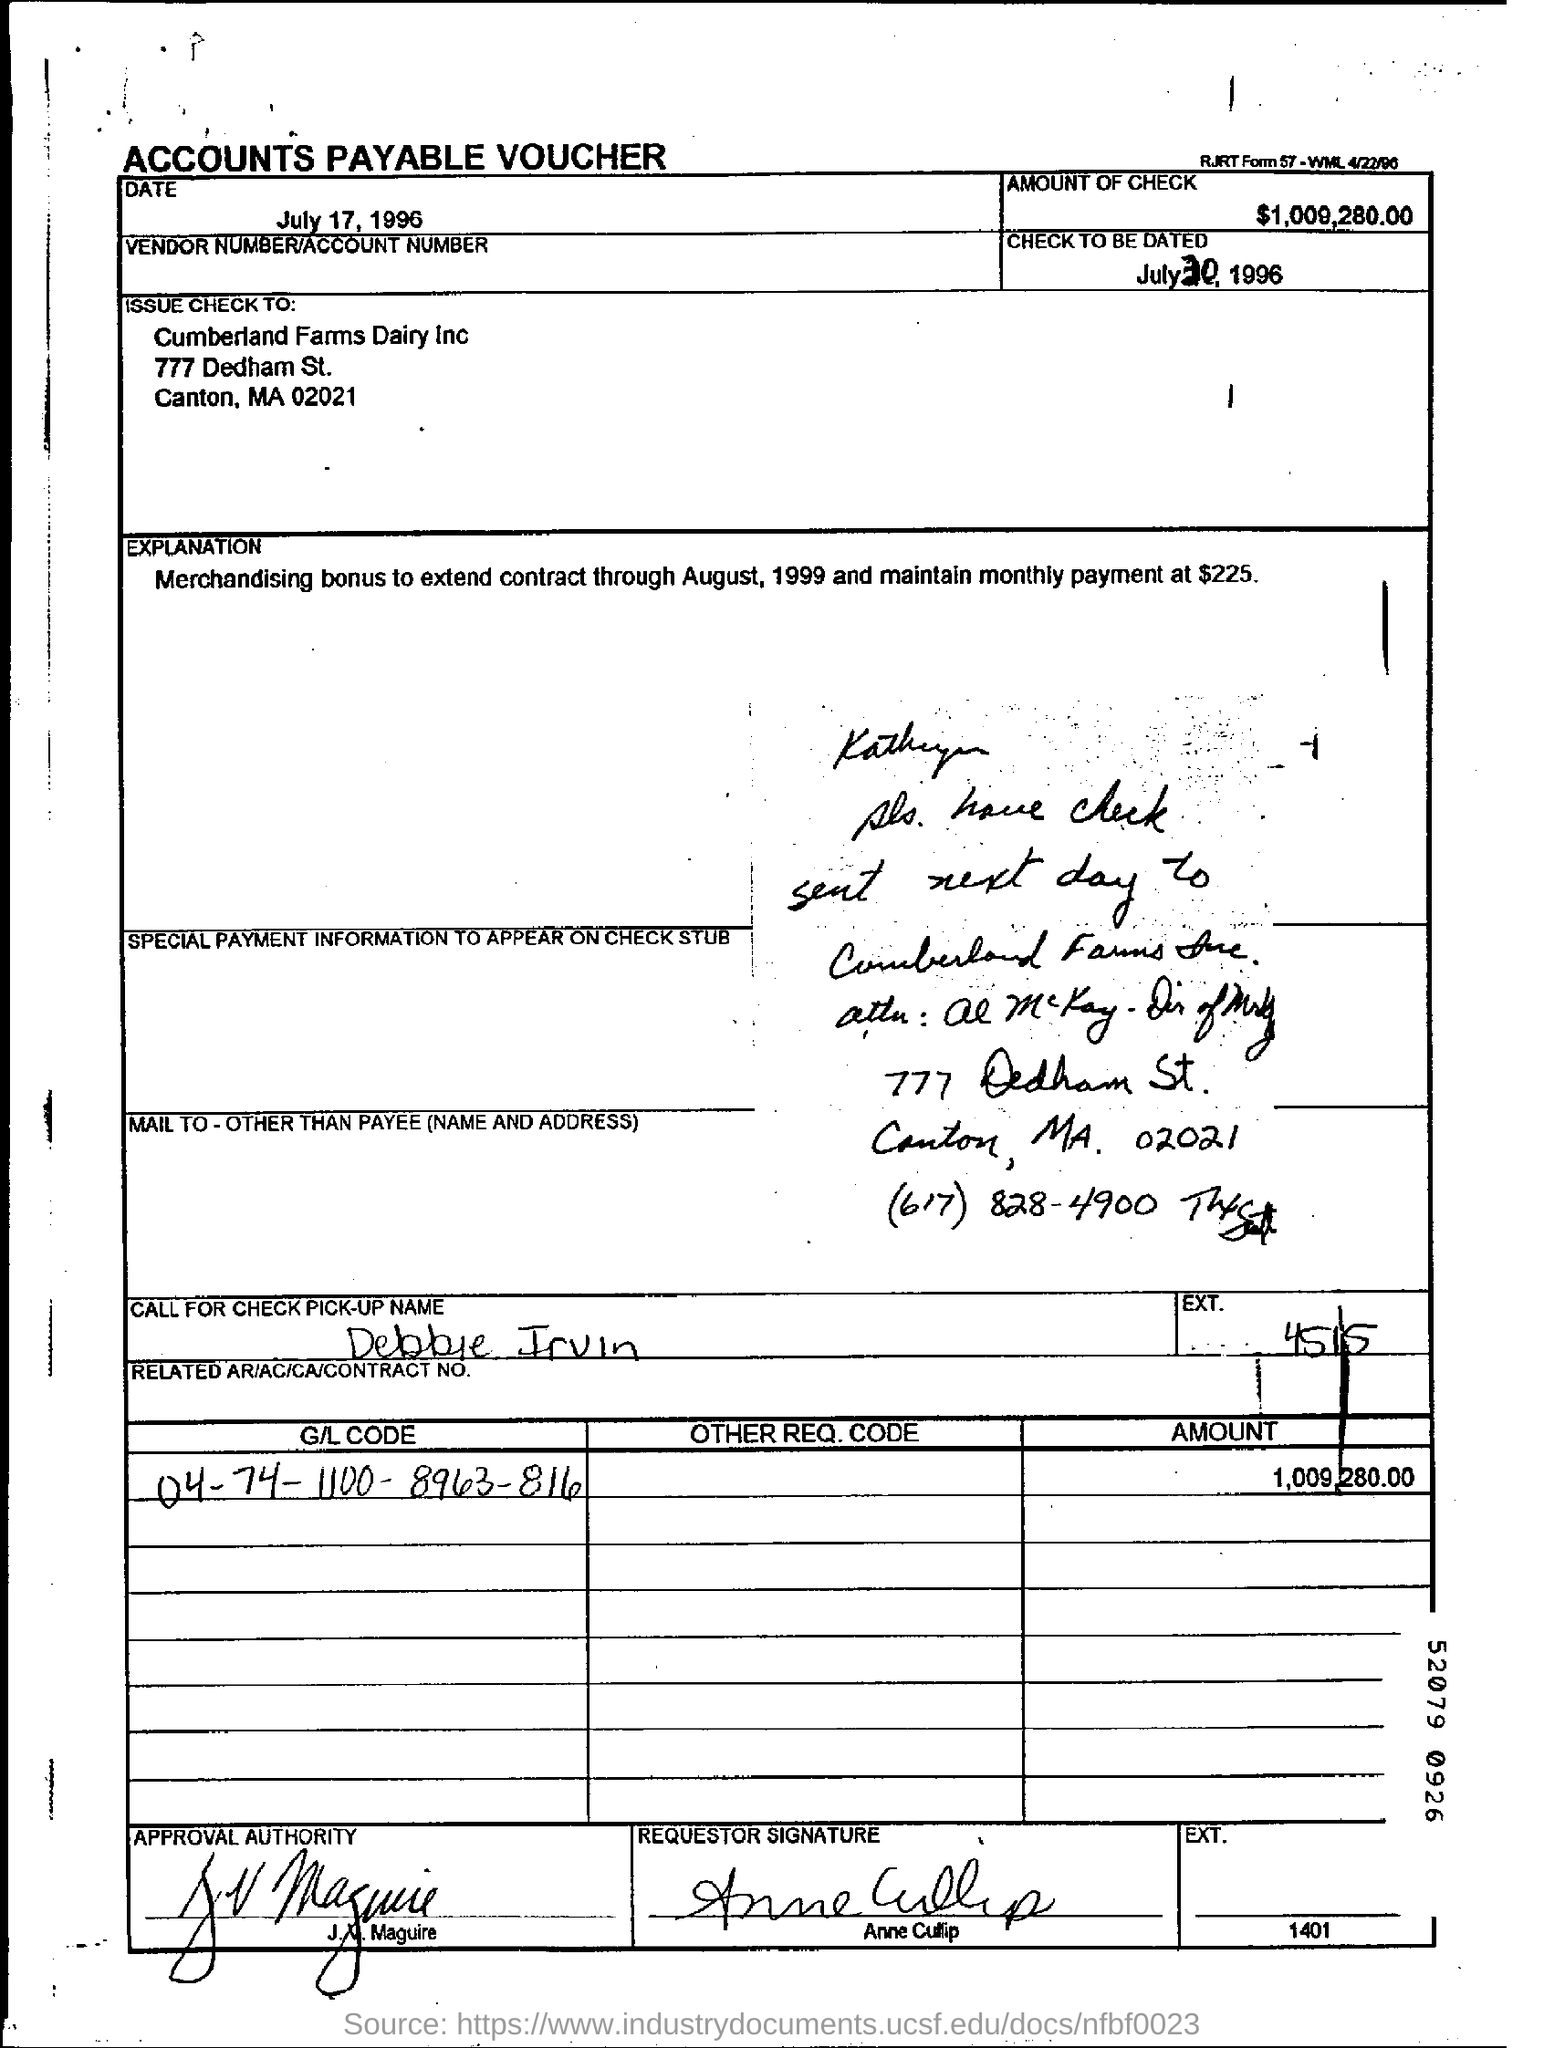What kind of voucher is this ?
Make the answer very short. ACCOUNTS PAYABLE VOUCHER. What is the amount of check mentioned in the voucher?
Provide a short and direct response. $1,009,280.00. What is the check to be dated?
Your answer should be compact. July 30, 1996. To which company , the check is issued to?
Your response must be concise. Cumberland Farms Dairy Inc. What is the G/L Code mentioned in the voucher?
Make the answer very short. 04-74-1100-8963-816. What is the EXT. No given in the voucher?
Provide a short and direct response. 4515. 